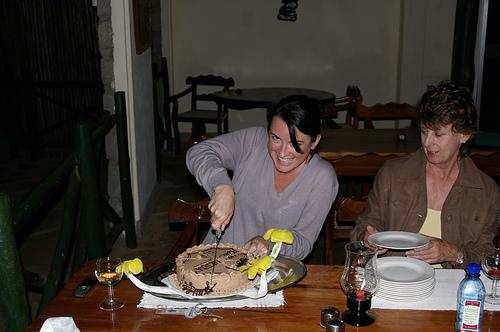Who is pointing at the food?
Write a very short answer. Woman. Are they on weight loss diets?
Write a very short answer. No. Are these people eating?
Answer briefly. Yes. Is he having lunch in a street cafe?
Quick response, please. No. How many women are in the picture?
Quick response, please. 2. What type of cake is she cutting?
Quick response, please. Chocolate. How many women are at the table?
Concise answer only. 2. Is all the wine gone?
Keep it brief. No. Is the woman cutting cake?
Keep it brief. Yes. Which utensils is the woman holding?
Write a very short answer. Knife. What color is the drink in the bottle?
Give a very brief answer. Clear. Is this a birthday party?
Keep it brief. Yes. 